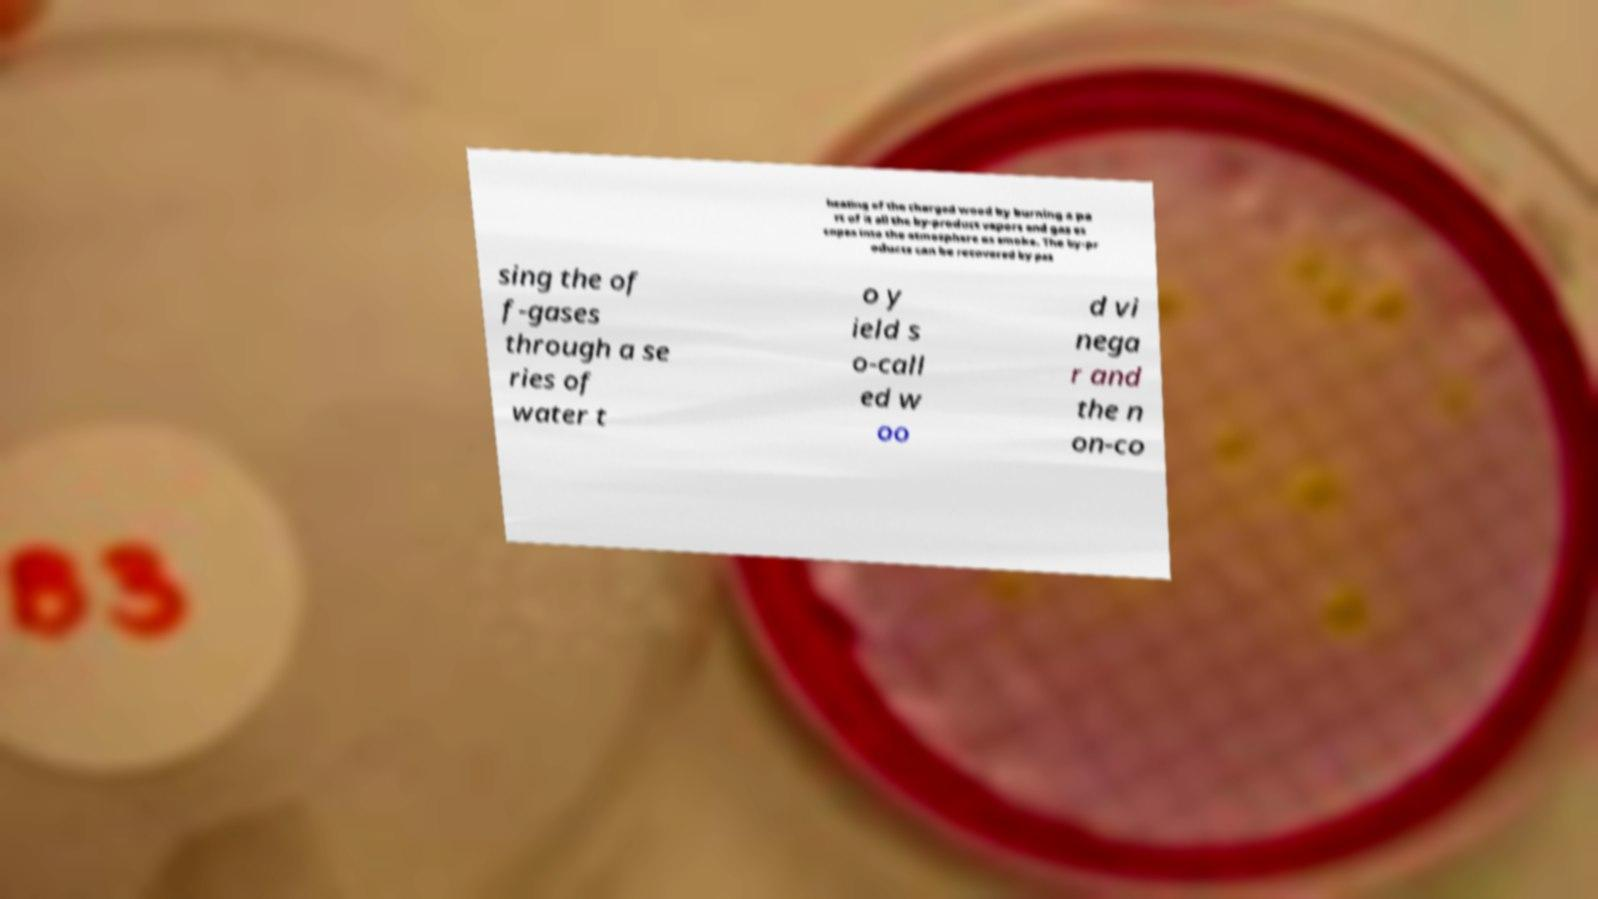There's text embedded in this image that I need extracted. Can you transcribe it verbatim? heating of the charged wood by burning a pa rt of it all the by-product vapors and gas es capes into the atmosphere as smoke. The by-pr oducts can be recovered by pas sing the of f-gases through a se ries of water t o y ield s o-call ed w oo d vi nega r and the n on-co 